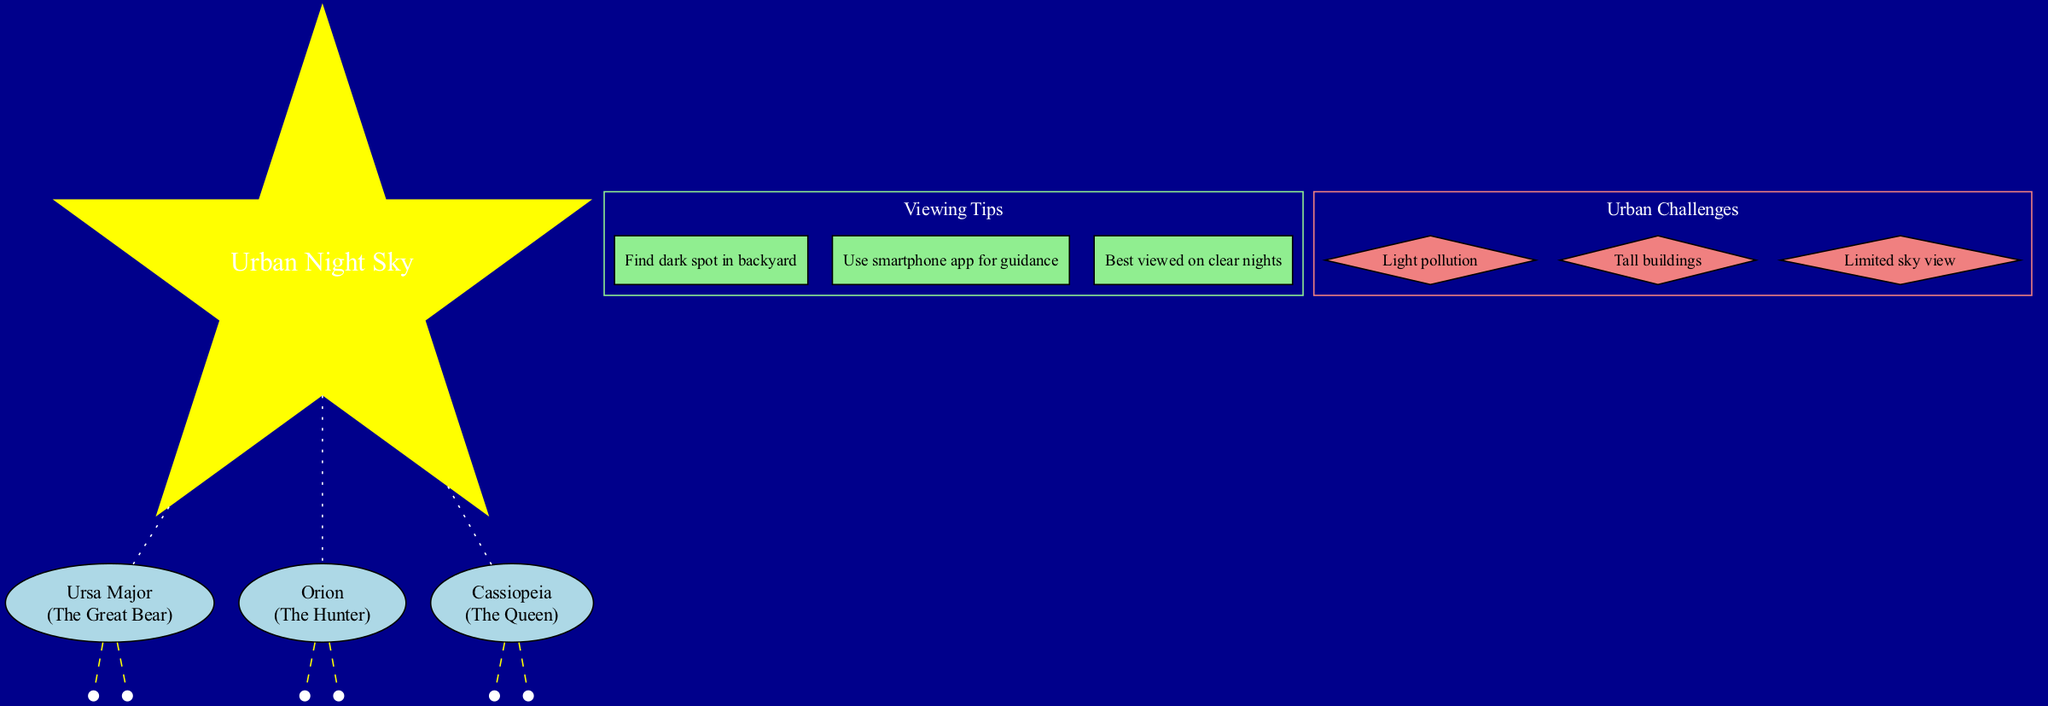What are the names of the constellations shown? The diagram lists three constellations: Ursa Major, Orion, and Cassiopeia. Each constellation is represented clearly and labeled with its name.
Answer: Ursa Major, Orion, Cassiopeia What is the mythology reference for Orion? The diagram shows that the mythology reference for Orion is "The Hunter." This information is located next to the constellation name.
Answer: The Hunter How many key stars are associated with Cassiopeia? In the diagram, Cassiopeia has two key stars listed: Schedar and Caph. This can be found in the section detailing its key stars.
Answer: 2 What is a viewing tip mentioned in the diagram? One of the viewing tips in the diagram is "Find dark spot in backyard." This is clearly listed under the viewing tips node.
Answer: Find dark spot in backyard Which constellation is associated with the key star Betelgeuse? Betelgeuse is listed as a key star under the constellation Orion. By following the edge connections, it is clear that Betelgeuse belongs to Orion.
Answer: Orion What challenges are stated regarding urban stargazing? The diagram lists three urban challenges: Light pollution, Tall buildings, and Limited sky view. These challenges are presented under their respective section.
Answer: Light pollution, Tall buildings, Limited sky view How many constellations have been labeled on this diagram? The diagram contains three labeled constellations: Ursa Major, Orion, and Cassiopeia. Each is distinctly represented, allowing for easy counting.
Answer: 3 What shape is used to represent the center node in the diagram? The center node is represented as a star shape, which is specified in the diagram's attributes for that node.
Answer: Star What color is used for the constellation nodes in the diagram? The constellation nodes are filled with light blue color as indicated in their styling within the diagram's code.
Answer: Light blue 